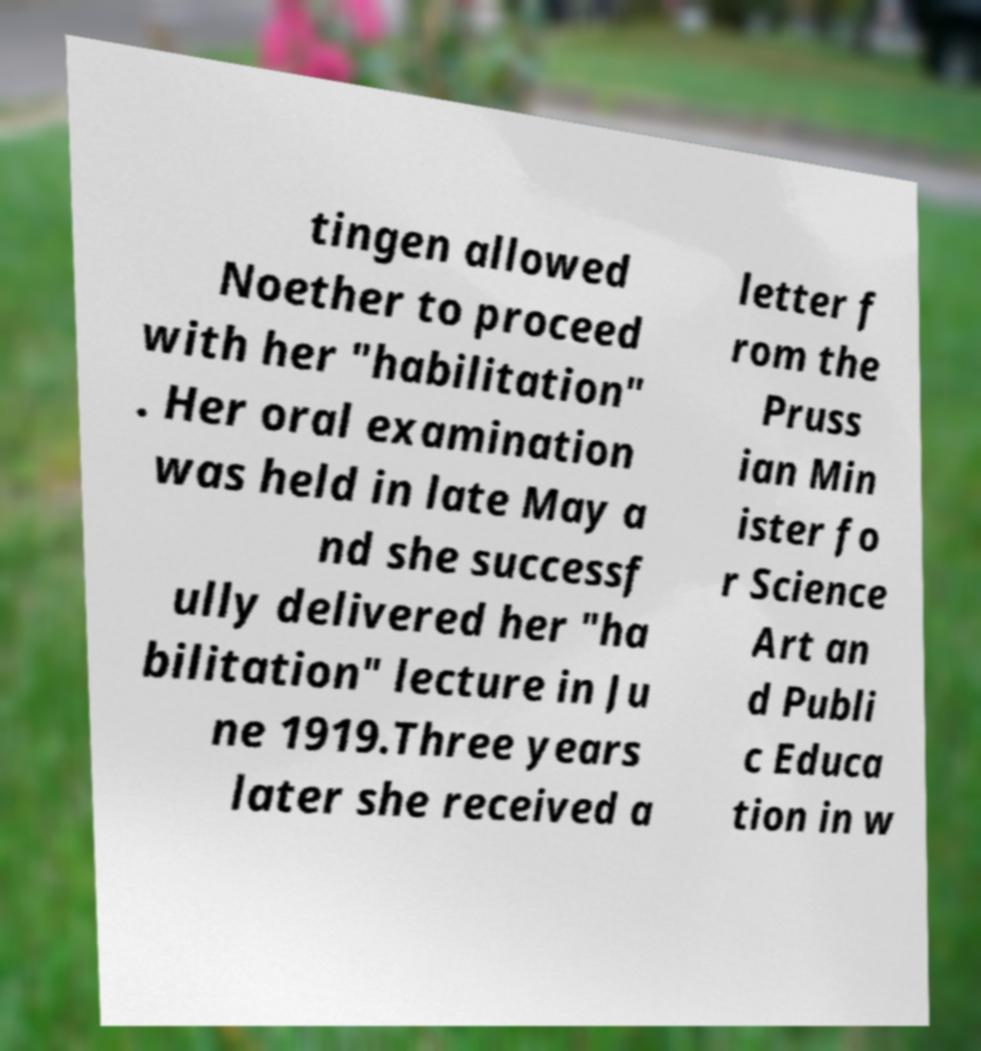For documentation purposes, I need the text within this image transcribed. Could you provide that? tingen allowed Noether to proceed with her "habilitation" . Her oral examination was held in late May a nd she successf ully delivered her "ha bilitation" lecture in Ju ne 1919.Three years later she received a letter f rom the Pruss ian Min ister fo r Science Art an d Publi c Educa tion in w 